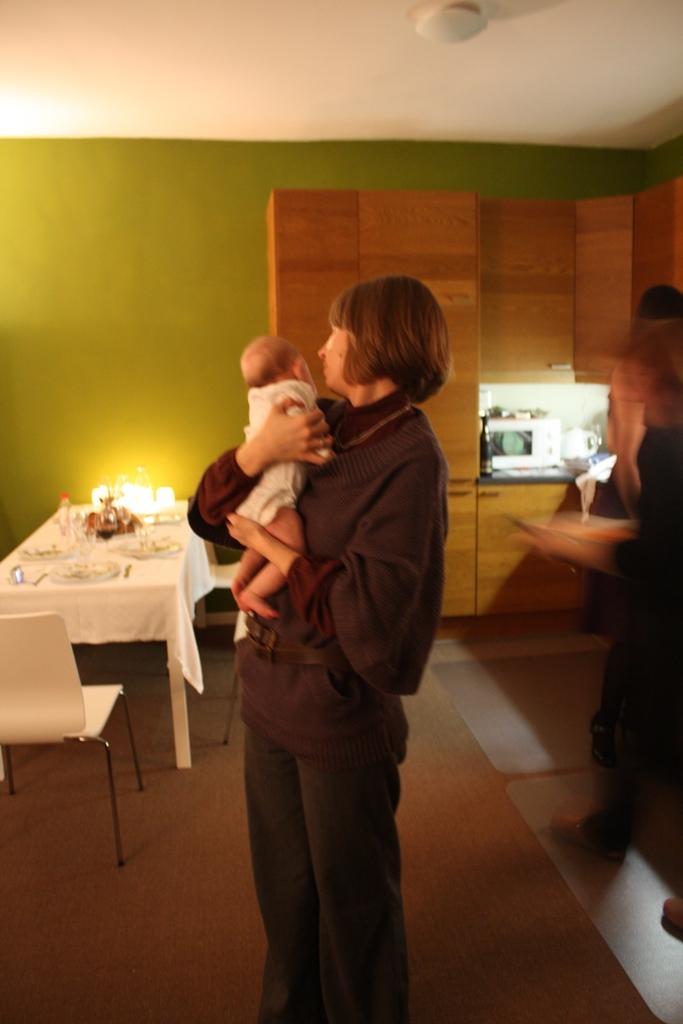In one or two sentences, can you explain what this image depicts? This picture shows a woman standing, holding a baby in her hands. In the background there is a table and chairs in front of a wall here. 